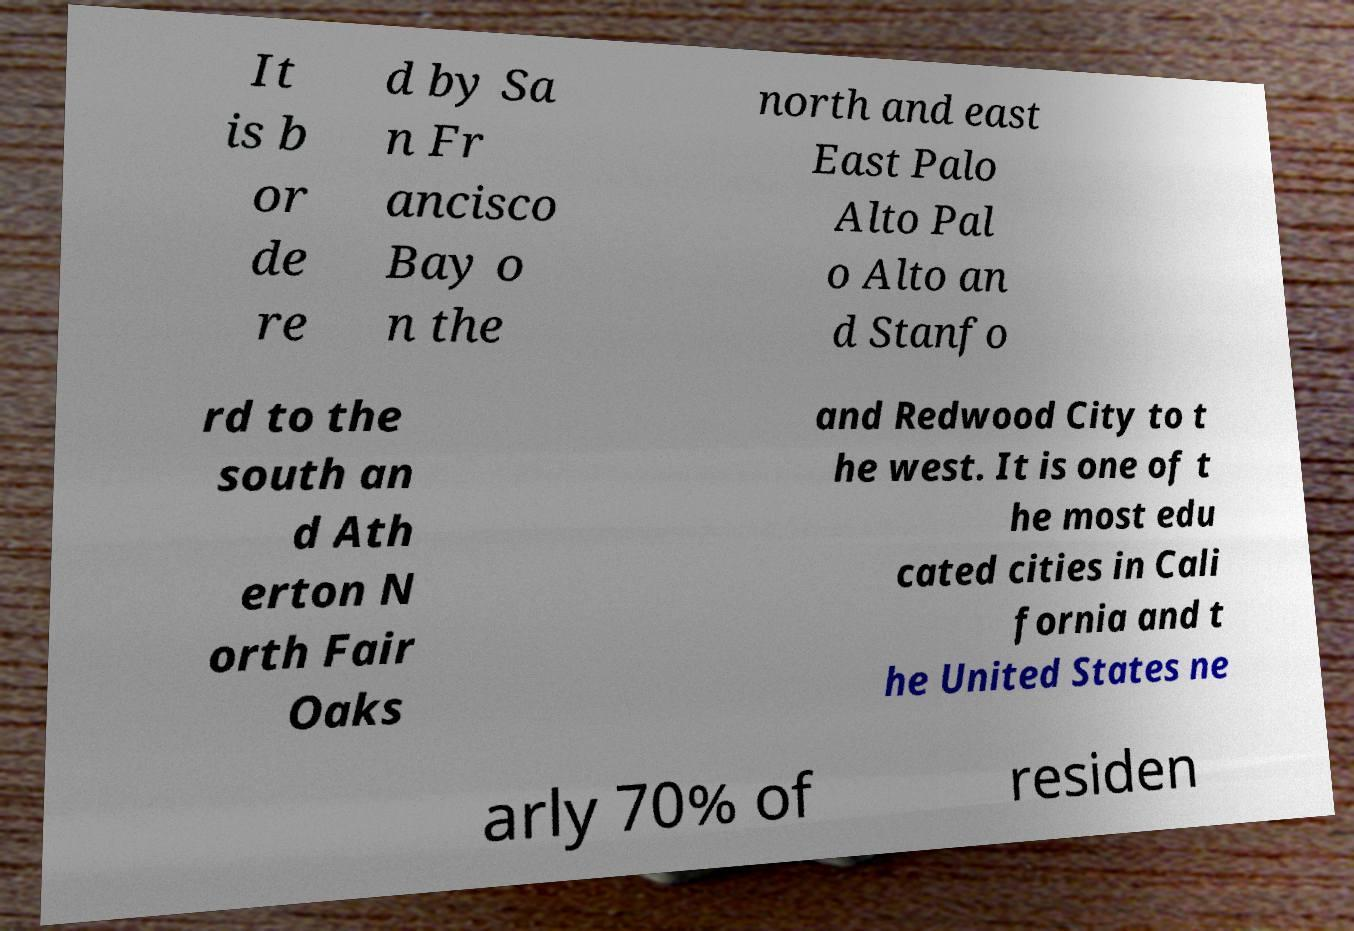What messages or text are displayed in this image? I need them in a readable, typed format. It is b or de re d by Sa n Fr ancisco Bay o n the north and east East Palo Alto Pal o Alto an d Stanfo rd to the south an d Ath erton N orth Fair Oaks and Redwood City to t he west. It is one of t he most edu cated cities in Cali fornia and t he United States ne arly 70% of residen 